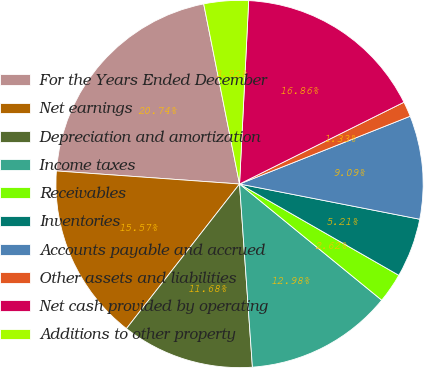Convert chart. <chart><loc_0><loc_0><loc_500><loc_500><pie_chart><fcel>For the Years Ended December<fcel>Net earnings<fcel>Depreciation and amortization<fcel>Income taxes<fcel>Receivables<fcel>Inventories<fcel>Accounts payable and accrued<fcel>Other assets and liabilities<fcel>Net cash provided by operating<fcel>Additions to other property<nl><fcel>20.74%<fcel>15.57%<fcel>11.68%<fcel>12.98%<fcel>2.62%<fcel>5.21%<fcel>9.09%<fcel>1.33%<fcel>16.86%<fcel>3.92%<nl></chart> 